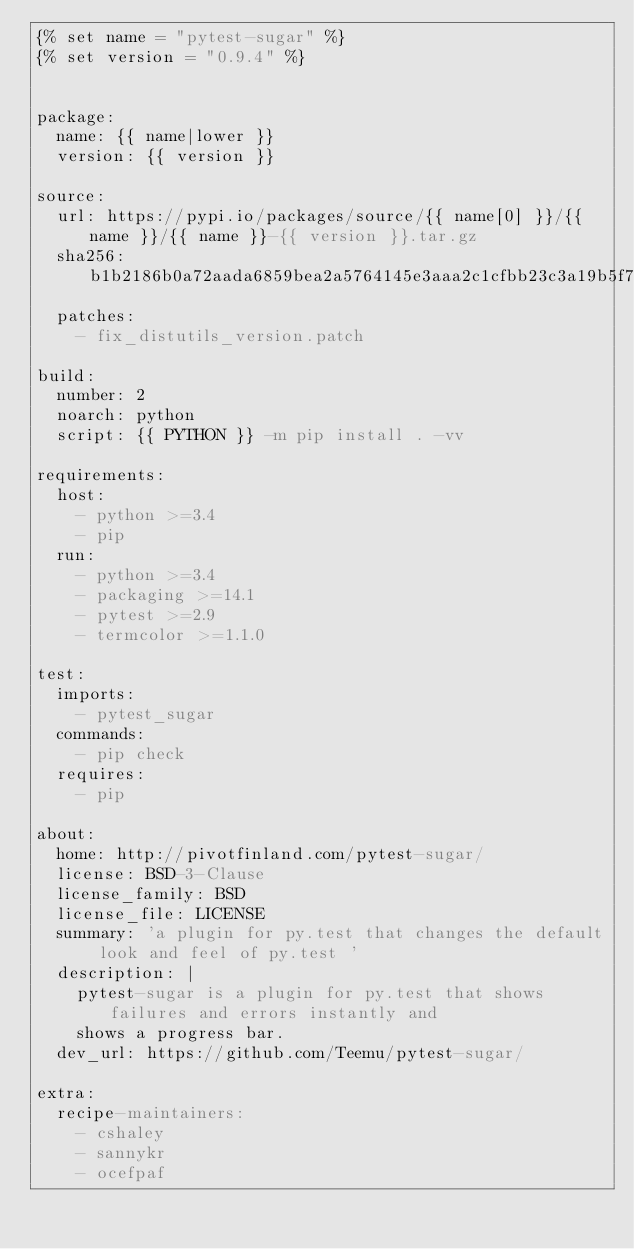<code> <loc_0><loc_0><loc_500><loc_500><_YAML_>{% set name = "pytest-sugar" %}
{% set version = "0.9.4" %}


package:
  name: {{ name|lower }}
  version: {{ version }}

source:
  url: https://pypi.io/packages/source/{{ name[0] }}/{{ name }}/{{ name }}-{{ version }}.tar.gz
  sha256: b1b2186b0a72aada6859bea2a5764145e3aaa2c1cfbb23c3a19b5f7b697563d3
  patches:
    - fix_distutils_version.patch

build:
  number: 2
  noarch: python
  script: {{ PYTHON }} -m pip install . -vv

requirements:
  host:
    - python >=3.4
    - pip
  run:
    - python >=3.4
    - packaging >=14.1
    - pytest >=2.9
    - termcolor >=1.1.0

test:
  imports:
    - pytest_sugar
  commands:
    - pip check
  requires:
    - pip

about:
  home: http://pivotfinland.com/pytest-sugar/
  license: BSD-3-Clause
  license_family: BSD
  license_file: LICENSE
  summary: 'a plugin for py.test that changes the default look and feel of py.test '
  description: |
    pytest-sugar is a plugin for py.test that shows failures and errors instantly and
    shows a progress bar.
  dev_url: https://github.com/Teemu/pytest-sugar/

extra:
  recipe-maintainers:
    - cshaley
    - sannykr
    - ocefpaf
</code> 